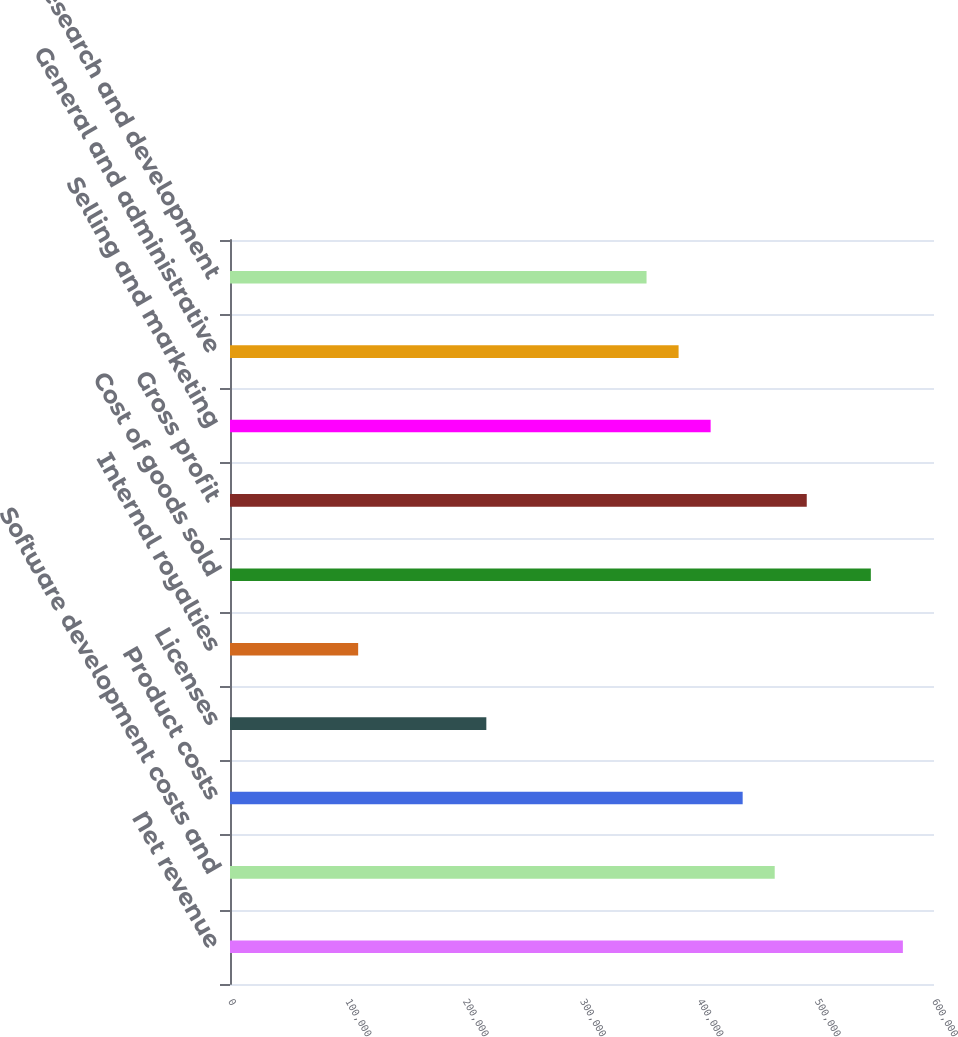Convert chart to OTSL. <chart><loc_0><loc_0><loc_500><loc_500><bar_chart><fcel>Net revenue<fcel>Software development costs and<fcel>Product costs<fcel>Licenses<fcel>Internal royalties<fcel>Cost of goods sold<fcel>Gross profit<fcel>Selling and marketing<fcel>General and administrative<fcel>Research and development<nl><fcel>573476<fcel>464243<fcel>436934<fcel>218467<fcel>109234<fcel>546168<fcel>491551<fcel>409626<fcel>382318<fcel>355009<nl></chart> 